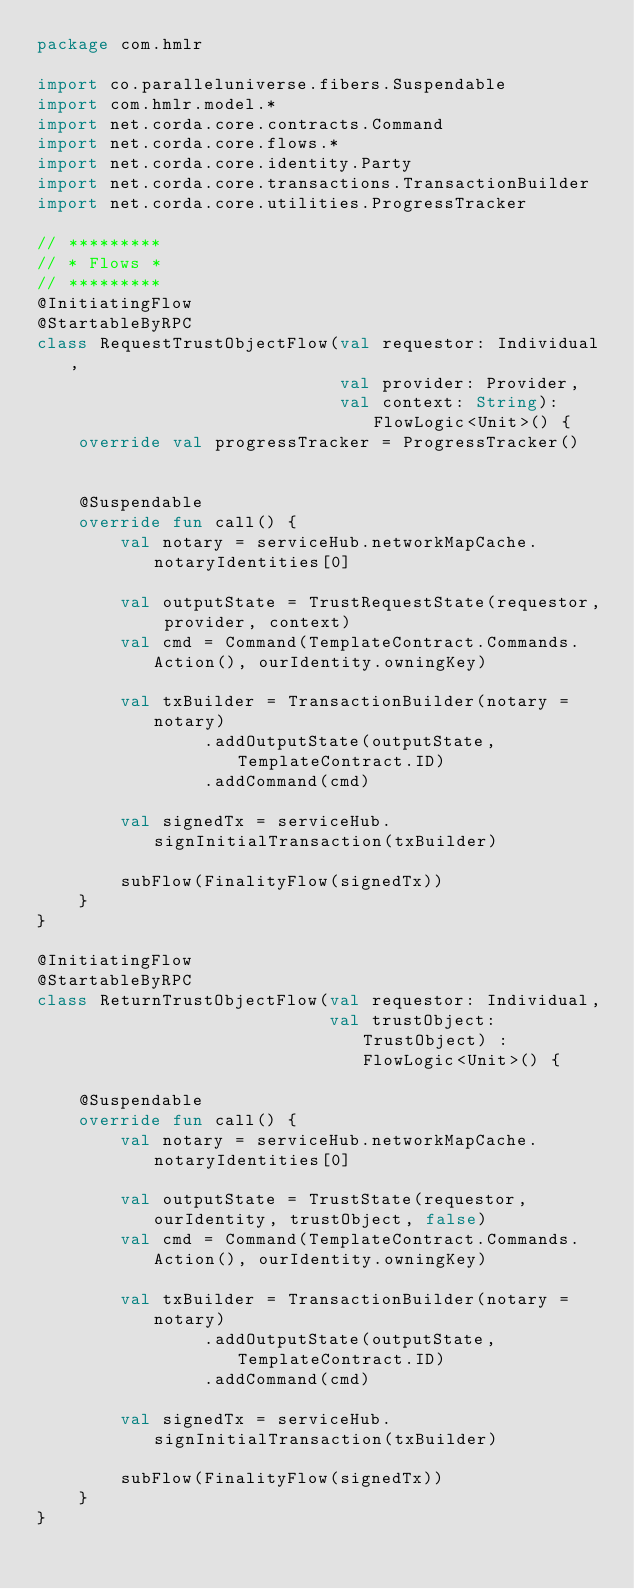<code> <loc_0><loc_0><loc_500><loc_500><_Kotlin_>package com.hmlr

import co.paralleluniverse.fibers.Suspendable
import com.hmlr.model.*
import net.corda.core.contracts.Command
import net.corda.core.flows.*
import net.corda.core.identity.Party
import net.corda.core.transactions.TransactionBuilder
import net.corda.core.utilities.ProgressTracker

// *********
// * Flows *
// *********
@InitiatingFlow
@StartableByRPC
class RequestTrustObjectFlow(val requestor: Individual,
                             val provider: Provider,
                             val context: String): FlowLogic<Unit>() {
    override val progressTracker = ProgressTracker()


    @Suspendable
    override fun call() {
        val notary = serviceHub.networkMapCache.notaryIdentities[0]

        val outputState = TrustRequestState(requestor, provider, context)
        val cmd = Command(TemplateContract.Commands.Action(), ourIdentity.owningKey)

        val txBuilder = TransactionBuilder(notary = notary)
                .addOutputState(outputState, TemplateContract.ID)
                .addCommand(cmd)

        val signedTx = serviceHub.signInitialTransaction(txBuilder)

        subFlow(FinalityFlow(signedTx))
    }
}

@InitiatingFlow
@StartableByRPC
class ReturnTrustObjectFlow(val requestor: Individual,
                            val trustObject: TrustObject) : FlowLogic<Unit>() {

    @Suspendable
    override fun call() {
        val notary = serviceHub.networkMapCache.notaryIdentities[0]

        val outputState = TrustState(requestor, ourIdentity, trustObject, false)
        val cmd = Command(TemplateContract.Commands.Action(), ourIdentity.owningKey)

        val txBuilder = TransactionBuilder(notary = notary)
                .addOutputState(outputState, TemplateContract.ID)
                .addCommand(cmd)

        val signedTx = serviceHub.signInitialTransaction(txBuilder)

        subFlow(FinalityFlow(signedTx))
    }
}
</code> 